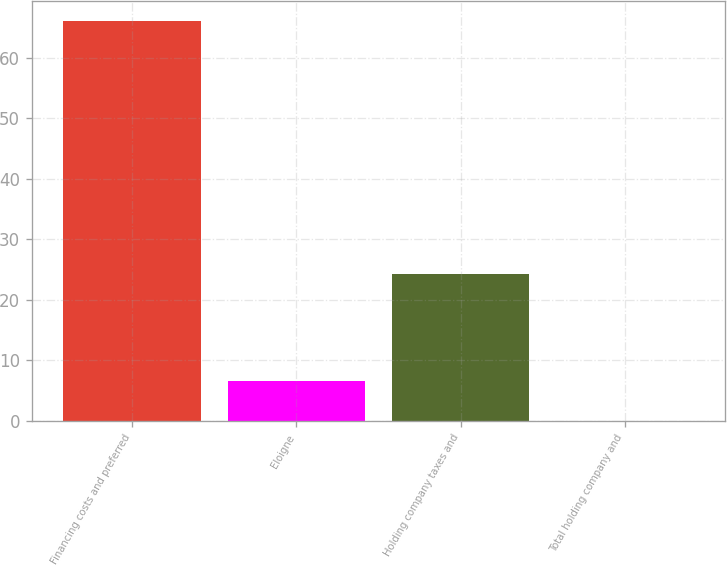Convert chart to OTSL. <chart><loc_0><loc_0><loc_500><loc_500><bar_chart><fcel>Financing costs and preferred<fcel>Eloigne<fcel>Holding company taxes and<fcel>Total holding company and<nl><fcel>66.1<fcel>6.66<fcel>24.2<fcel>0.06<nl></chart> 